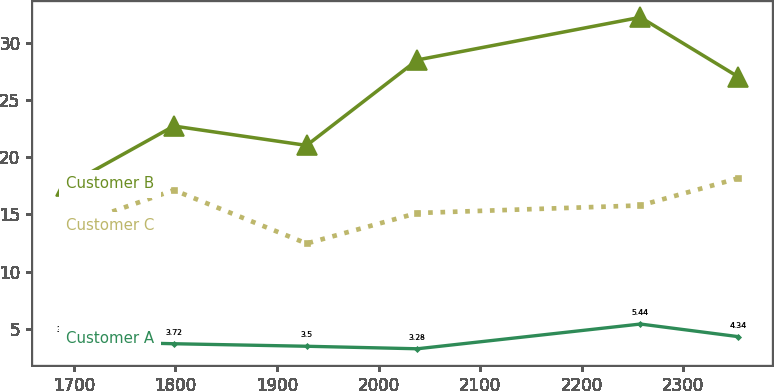Convert chart to OTSL. <chart><loc_0><loc_0><loc_500><loc_500><line_chart><ecel><fcel>Customer B<fcel>Customer C<fcel>Customer A<nl><fcel>1691.94<fcel>17.47<fcel>13.83<fcel>3.94<nl><fcel>1798.51<fcel>22.72<fcel>17.13<fcel>3.72<nl><fcel>1929.18<fcel>21.03<fcel>12.47<fcel>3.5<nl><fcel>2038.19<fcel>28.49<fcel>15.13<fcel>3.28<nl><fcel>2257.79<fcel>32.21<fcel>15.79<fcel>5.44<nl><fcel>2354.01<fcel>27.02<fcel>18.16<fcel>4.34<nl></chart> 